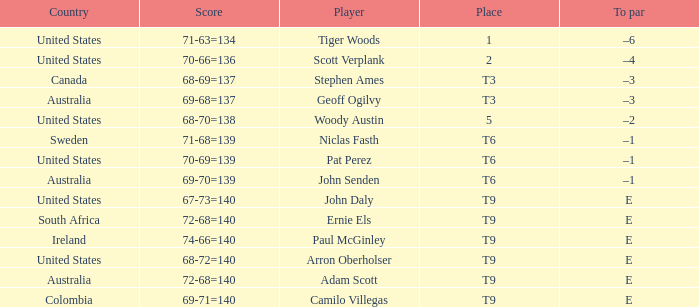What is Canada's score? 68-69=137. 